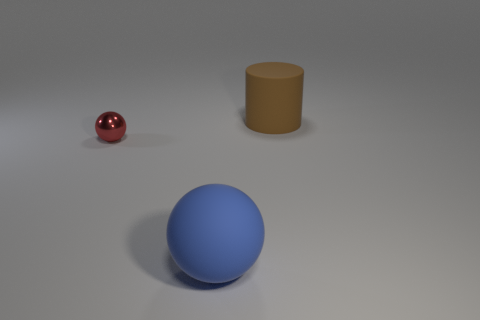Add 1 large red matte blocks. How many objects exist? 4 Subtract all cylinders. How many objects are left? 2 Add 3 big gray shiny things. How many big gray shiny things exist? 3 Subtract 0 green balls. How many objects are left? 3 Subtract all red metal spheres. Subtract all small red balls. How many objects are left? 1 Add 3 big rubber cylinders. How many big rubber cylinders are left? 4 